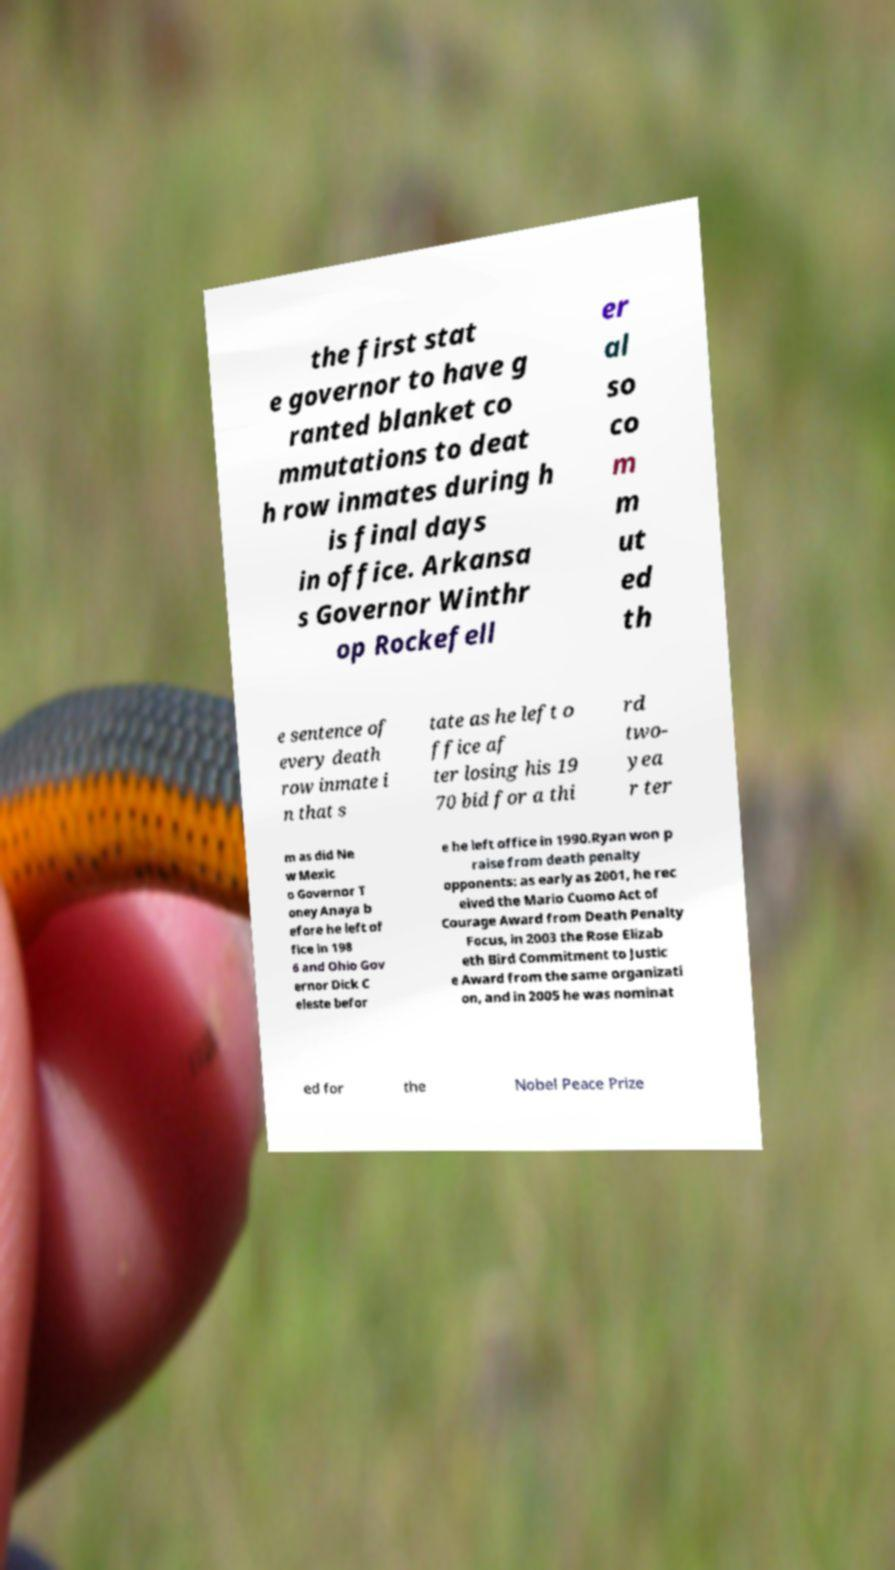Could you assist in decoding the text presented in this image and type it out clearly? the first stat e governor to have g ranted blanket co mmutations to deat h row inmates during h is final days in office. Arkansa s Governor Winthr op Rockefell er al so co m m ut ed th e sentence of every death row inmate i n that s tate as he left o ffice af ter losing his 19 70 bid for a thi rd two- yea r ter m as did Ne w Mexic o Governor T oney Anaya b efore he left of fice in 198 6 and Ohio Gov ernor Dick C eleste befor e he left office in 1990.Ryan won p raise from death penalty opponents: as early as 2001, he rec eived the Mario Cuomo Act of Courage Award from Death Penalty Focus, in 2003 the Rose Elizab eth Bird Commitment to Justic e Award from the same organizati on, and in 2005 he was nominat ed for the Nobel Peace Prize 